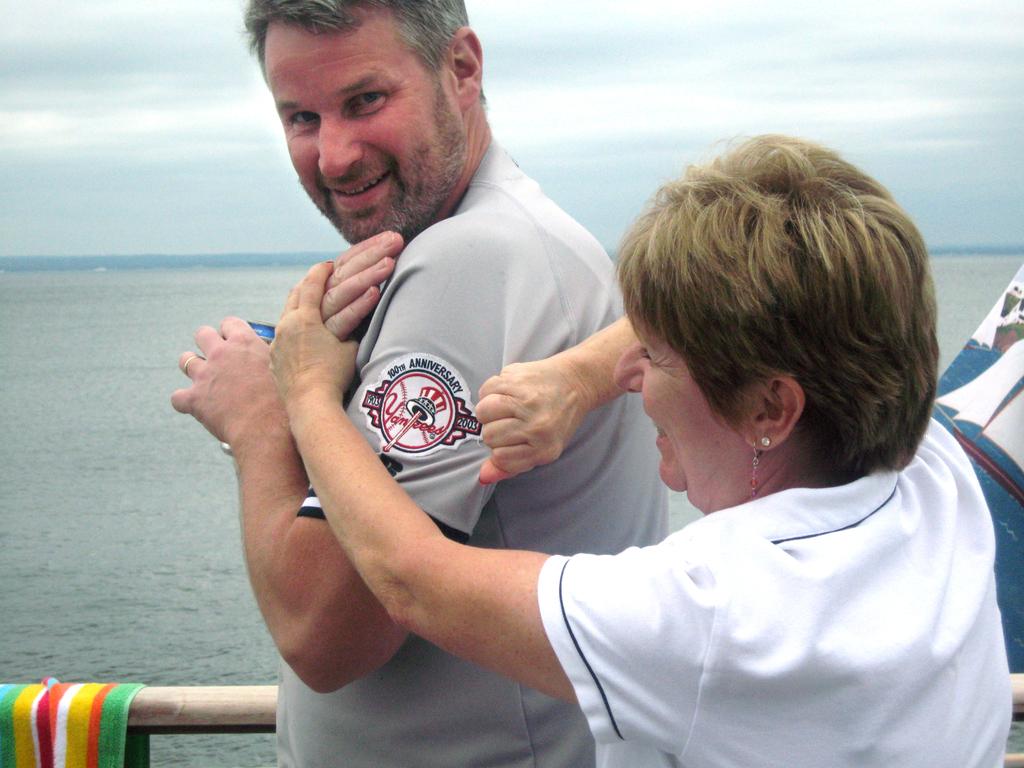Do you think they are yankee fans?
Your answer should be compact. Yes. What team is on the shirt?
Offer a terse response. Yankees. 